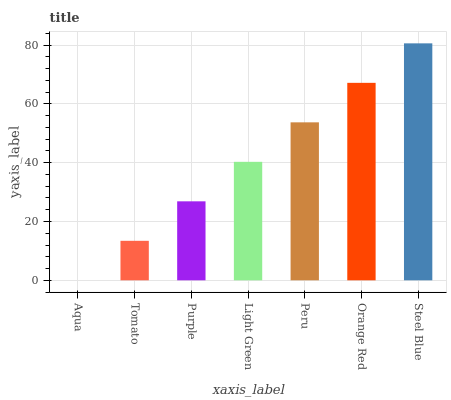Is Aqua the minimum?
Answer yes or no. Yes. Is Steel Blue the maximum?
Answer yes or no. Yes. Is Tomato the minimum?
Answer yes or no. No. Is Tomato the maximum?
Answer yes or no. No. Is Tomato greater than Aqua?
Answer yes or no. Yes. Is Aqua less than Tomato?
Answer yes or no. Yes. Is Aqua greater than Tomato?
Answer yes or no. No. Is Tomato less than Aqua?
Answer yes or no. No. Is Light Green the high median?
Answer yes or no. Yes. Is Light Green the low median?
Answer yes or no. Yes. Is Aqua the high median?
Answer yes or no. No. Is Steel Blue the low median?
Answer yes or no. No. 